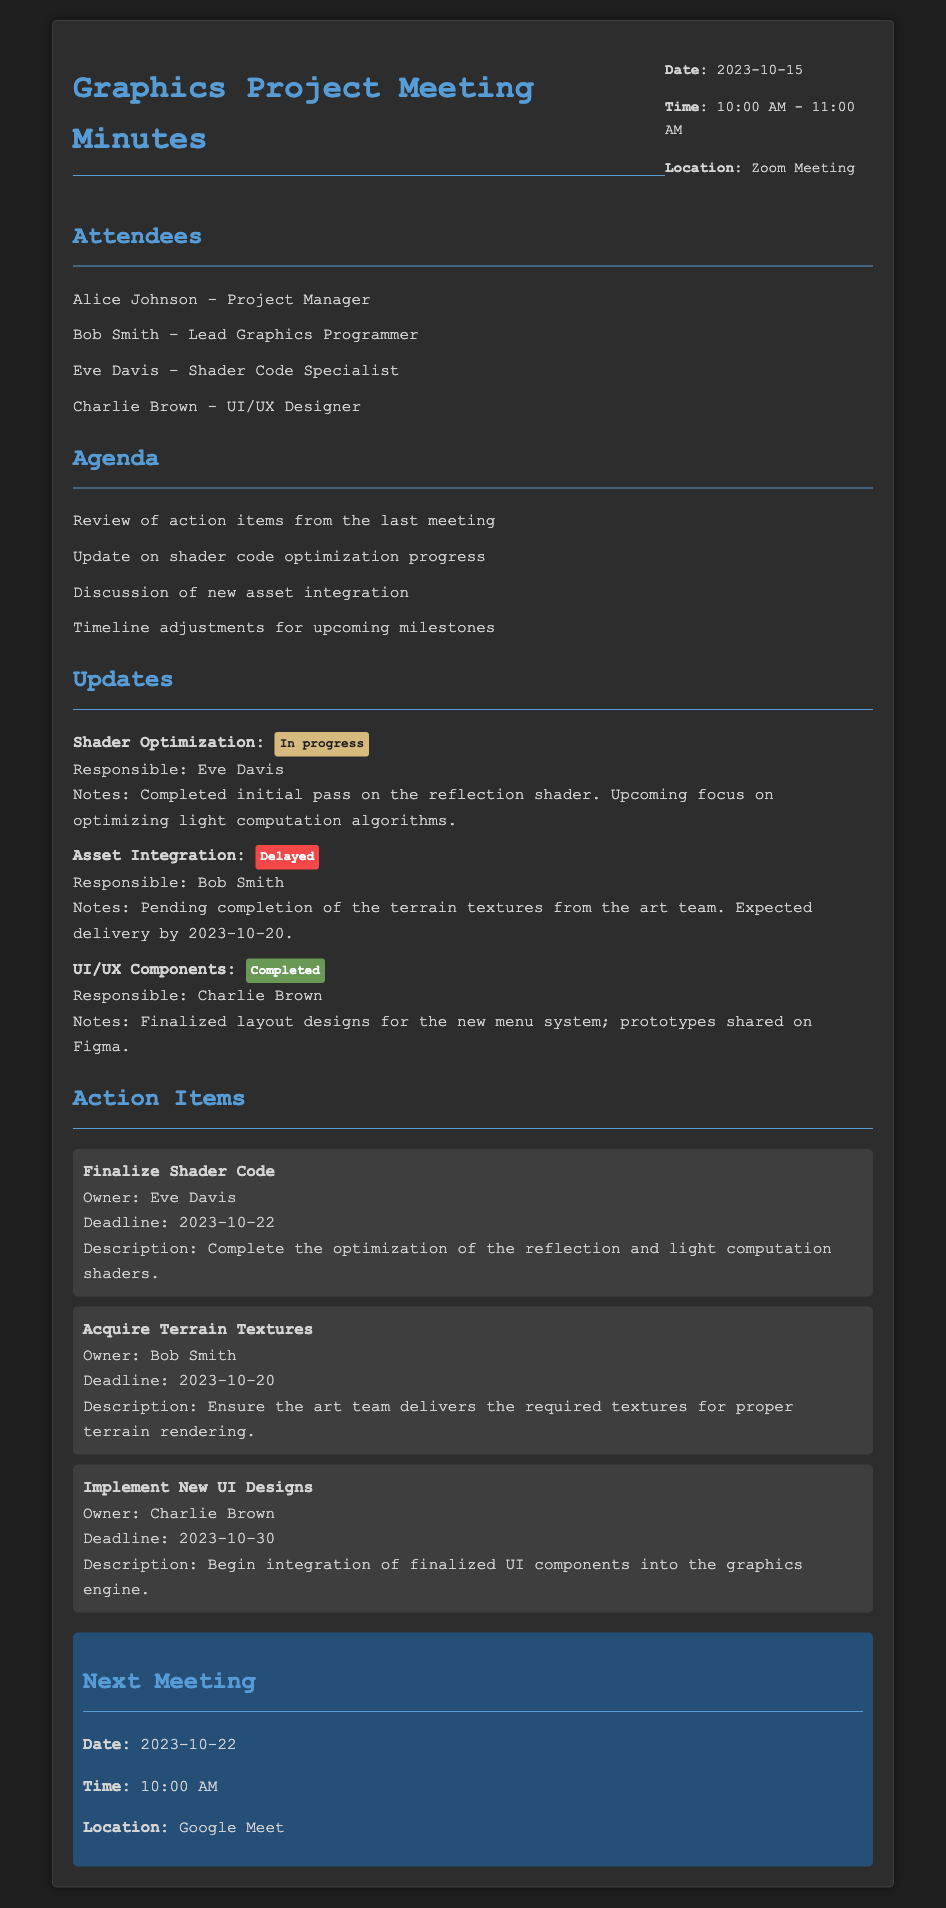what is the date of the meeting? The date of the meeting is mentioned prominently in the header section of the document.
Answer: 2023-10-15 who is responsible for shader optimization? The document specifies the responsibilities of team members for various action items, including shader optimization.
Answer: Eve Davis what is the status of asset integration? The status of each item is indicated along with responsibilities and notes in the updates section.
Answer: Delayed what is the deadline for acquiring terrain textures? The action item section clearly lists deadlines associated with each task.
Answer: 2023-10-20 how many attendees were present at the meeting? The attendees' list at the beginning of the document counts the total members present.
Answer: 4 what are the next meeting details? The next meeting section summarizes the date, time, and location for the following meeting.
Answer: 2023-10-22, 10:00 AM, Google Meet what is the action item for Charlie Brown? The action item section details the tasks assigned to each member, including Charlie Brown's responsibility.
Answer: Implement New UI Designs what is the upcoming focus for shader optimization? The notes section under updates provides insights on the next steps planned for shader optimization.
Answer: Optimizing light computation algorithms what is the title of the document? The title is prominently displayed at the top of the document, indicating its content focus.
Answer: Graphics Project Meeting Minutes 